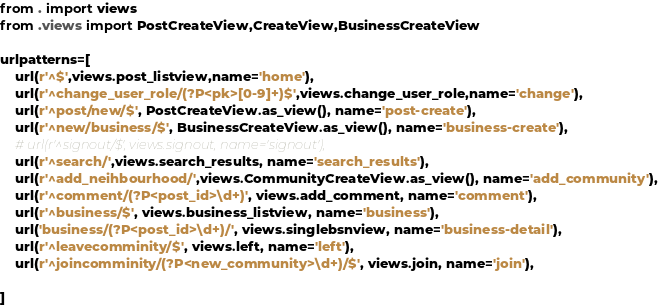Convert code to text. <code><loc_0><loc_0><loc_500><loc_500><_Python_>from . import views
from .views import PostCreateView,CreateView,BusinessCreateView

urlpatterns=[
    url(r'^$',views.post_listview,name='home'),
    url(r'^change_user_role/(?P<pk>[0-9]+)$',views.change_user_role,name='change'),
    url(r'^post/new/$', PostCreateView.as_view(), name='post-create'),
    url(r'^new/business/$', BusinessCreateView.as_view(), name='business-create'),
    # url(r'^signout/$', views.signout, name='signout'),
    url(r'^search/',views.search_results, name='search_results'),
    url(r'^add_neihbourhood/',views.CommunityCreateView.as_view(), name='add_community'),
    url(r'^comment/(?P<post_id>\d+)', views.add_comment, name='comment'),
    url(r'^business/$', views.business_listview, name='business'),
    url('business/(?P<post_id>\d+)/', views.singlebsnview, name='business-detail'),
    url(r'^leavecomminity/$', views.left, name='left'),
    url(r'^joincomminity/(?P<new_community>\d+)/$', views.join, name='join'),

]</code> 